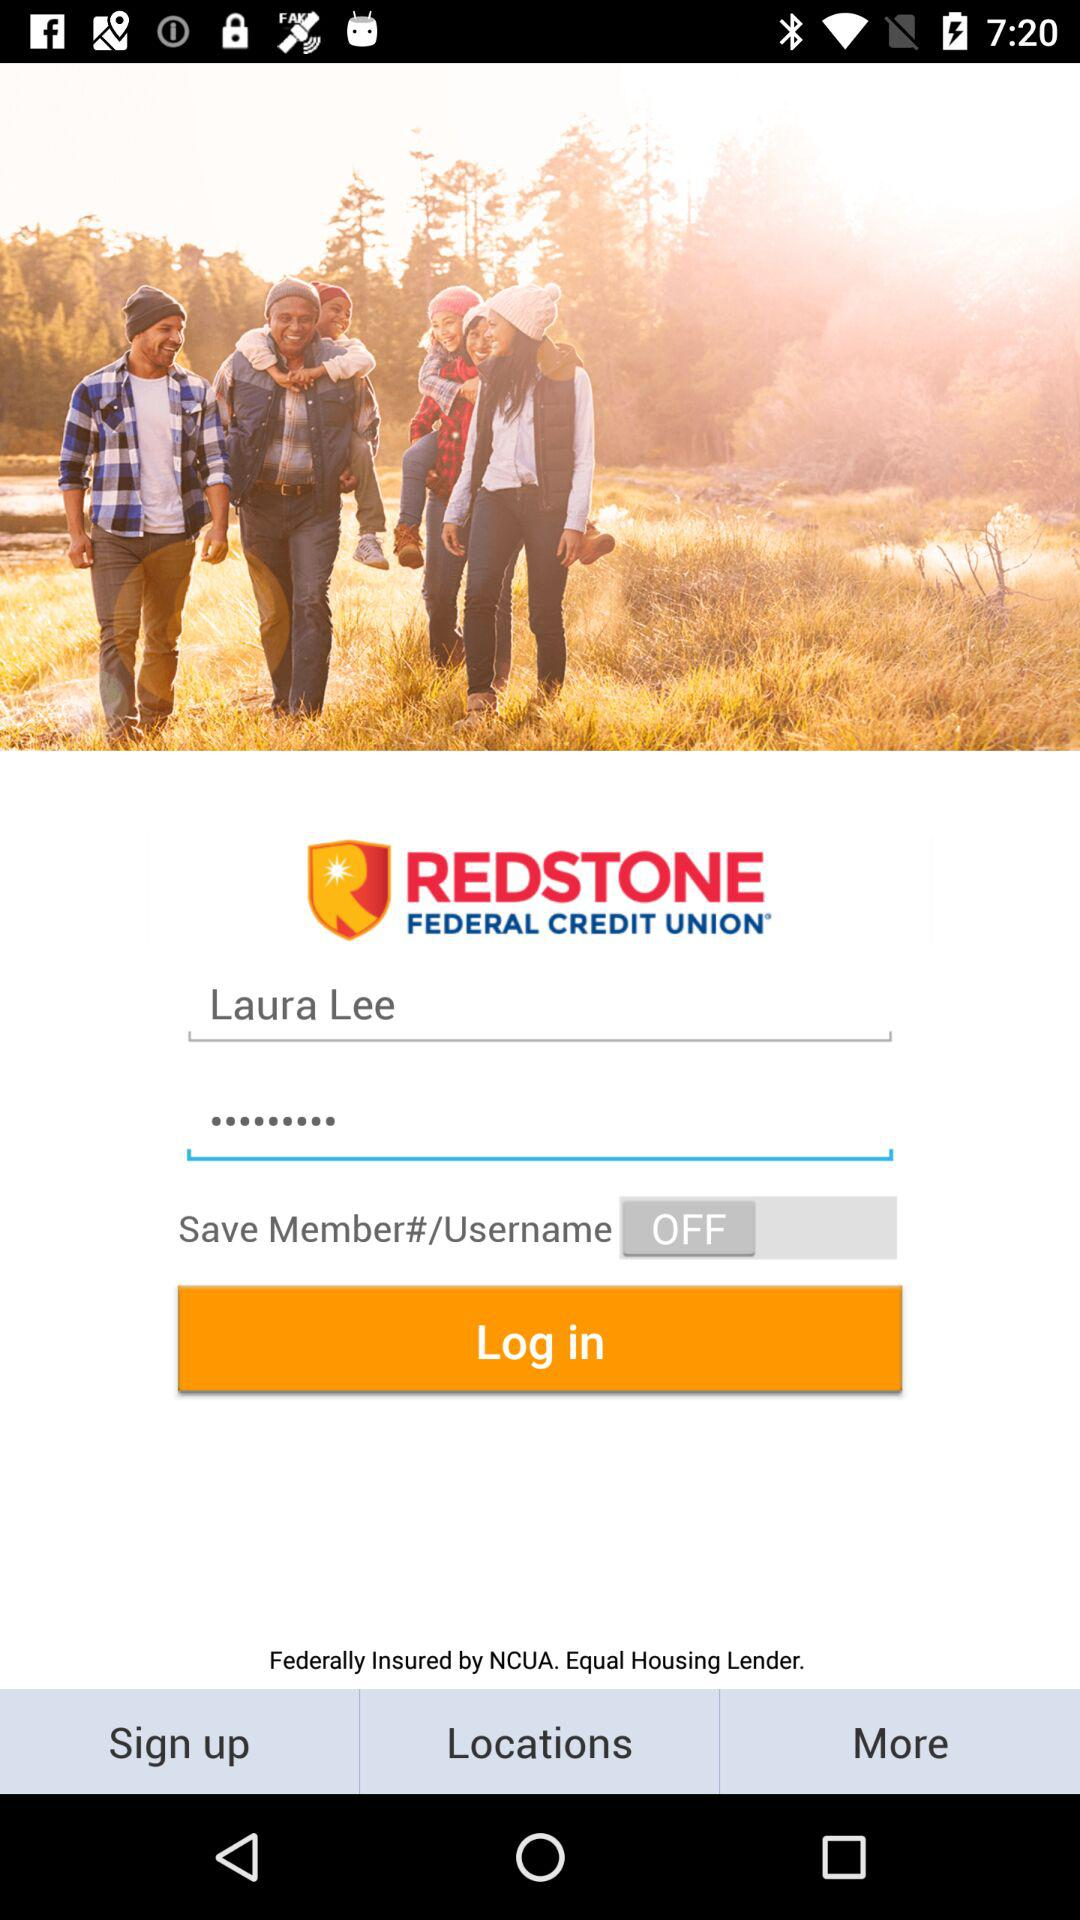What is the status of "Save Member"? The status of "Save Member" is "off". 